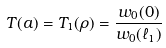<formula> <loc_0><loc_0><loc_500><loc_500>T ( a ) = T _ { 1 } ( \rho ) = \frac { w _ { 0 } ( 0 ) } { w _ { 0 } ( \ell _ { 1 } ) }</formula> 